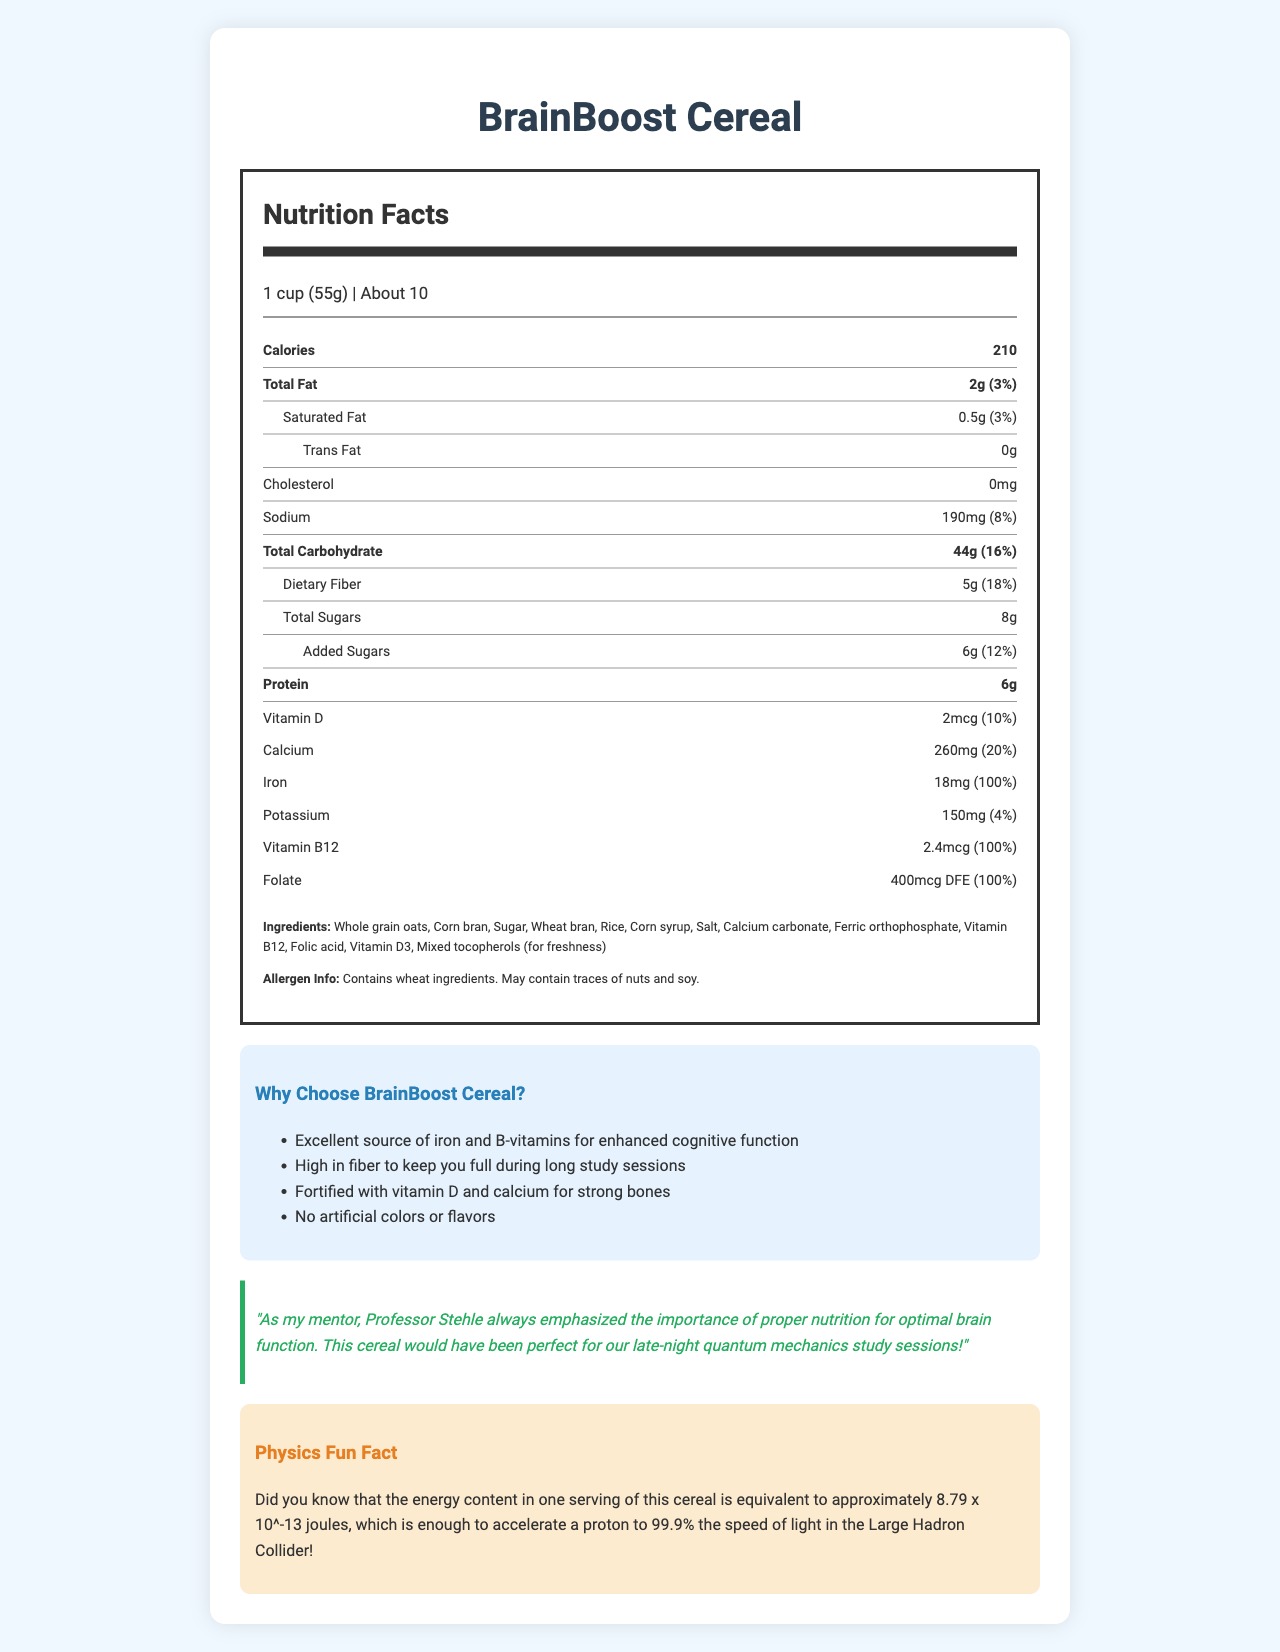what is the serving size for BrainBoost Cereal? The serving size for BrainBoost Cereal is clearly mentioned at the top of the Nutrition Facts label as "1 cup (55g)".
Answer: 1 cup (55g) how many servings are there per container? The serving information states that there are about 10 servings per container of BrainBoost Cereal.
Answer: About 10 how much total fat does one serving contain? The document states the total fat content per serving is 2g.
Answer: 2g how much added sugar is in one serving? The amount of added sugars per serving is mentioned as 6g.
Answer: 6g how much protein is in one serving of BrainBoost Cereal? The Nutrition Facts label shows that one serving contains 6g of protein.
Answer: 6g how much dietary fiber is in one serving of BrainBoost Cereal? The dietary fiber content per serving is listed as 5g.
Answer: 5g what is the percentage daily value of iron per serving? A. 50% B. 100% C. 25% D. 75% The document indicates that the iron content per serving is 18mg, which is 100% of the daily value.
Answer: B. 100% which of the following is not one of the marketing claims for BrainBoost Cereal? A. Excellent source of iron and B-vitamins B. Low in cholesterol C. High in fiber D. No artificial colors or flavors The marketing claims listed do not mention anything about being low in cholesterol. The actual marketing claims are focused on iron, B-vitamins, fiber, and absence of artificial colors or flavors.
Answer: B. Low in cholesterol does the cereal contain any artificial colors or flavors? One of the marketing claims specifically mentions that BrainBoost Cereal contains no artificial colors or flavors.
Answer: No describe the main idea of the document The document provides detailed nutrition information about BrainBoost Cereal, its ingredients, allergen information, and various marketing claims that highlight its benefits for college students.
Answer: BrainBoost Cereal is a vitamin-fortified cereal marketed towards health-conscious college students. It boasts high nutritional value, including high iron, fiber, and several essential vitamins. The cereal is designed to enhance cognitive function and keep consumers energized during study sessions. who is Professor Stehle? The document includes a quote mentioning Professor Stehle, but it does not provide any further information about who Professor Stehle is.
Answer: Not enough information 